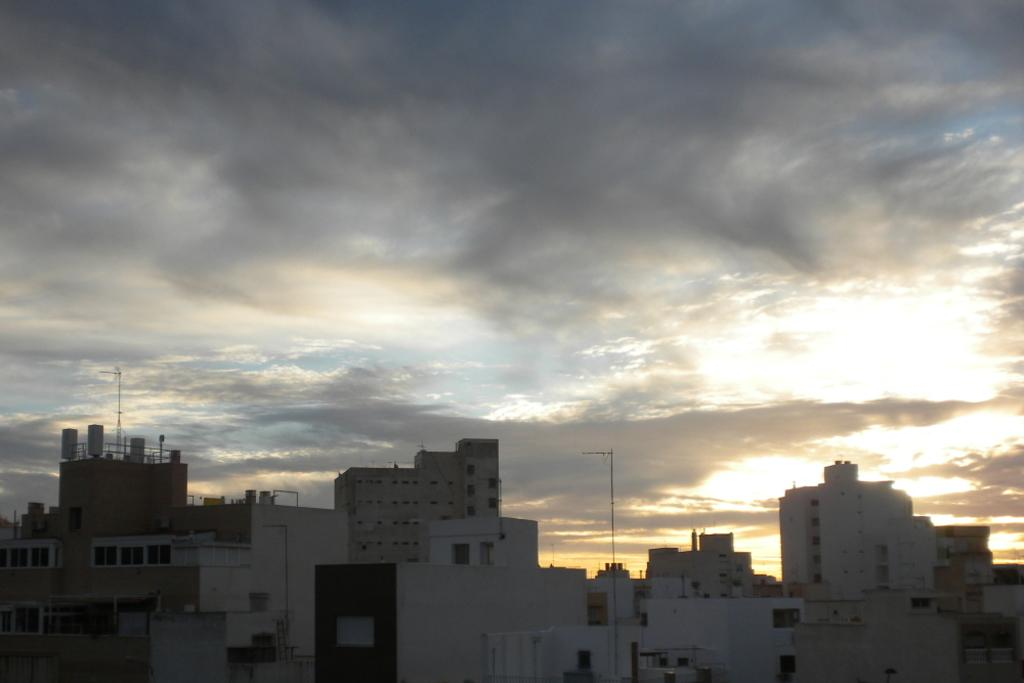What type of structures can be seen in the image? There are buildings in the image. What else is present in the image besides the buildings? There are poles in the image. What part of the natural environment is visible in the image? The sky is visible in the image. What can be seen in the sky? Clouds are present in the sky. Where is the mark made by the aunt's mice in the image? There is no mark made by the aunt's mice in the image, as there is no mention of mice or an aunt in the provided facts. 